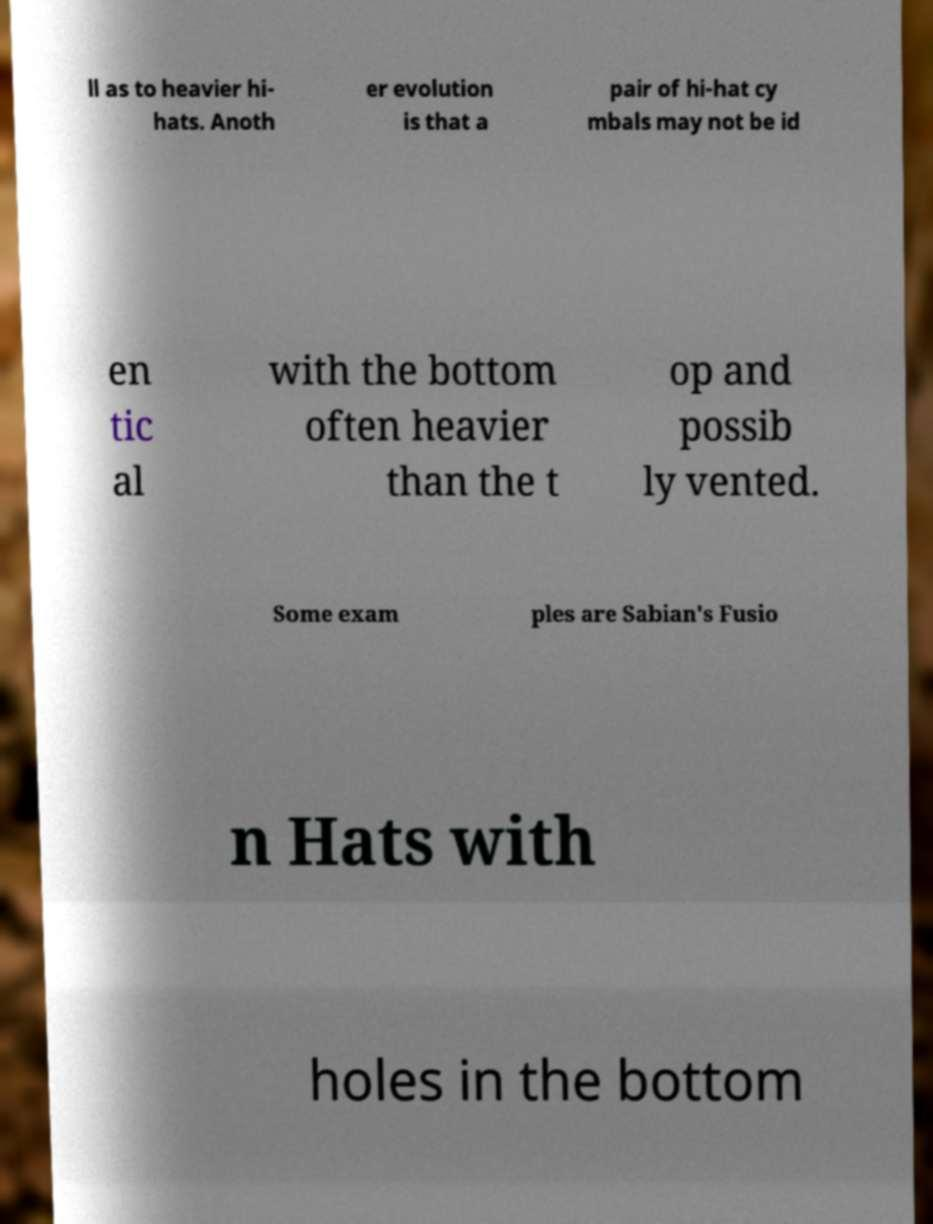I need the written content from this picture converted into text. Can you do that? ll as to heavier hi- hats. Anoth er evolution is that a pair of hi-hat cy mbals may not be id en tic al with the bottom often heavier than the t op and possib ly vented. Some exam ples are Sabian's Fusio n Hats with holes in the bottom 